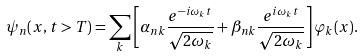Convert formula to latex. <formula><loc_0><loc_0><loc_500><loc_500>\psi _ { n } ( x , t > T ) = \sum _ { k } \left [ \alpha _ { n k } \frac { { e ^ { - i \omega _ { k } t } } } { \sqrt { 2 \omega _ { k } } } + \beta _ { n k } \frac { { e ^ { i \omega _ { k } t } } } { \sqrt { 2 \omega _ { k } } } \right ] \varphi _ { k } ( x ) .</formula> 